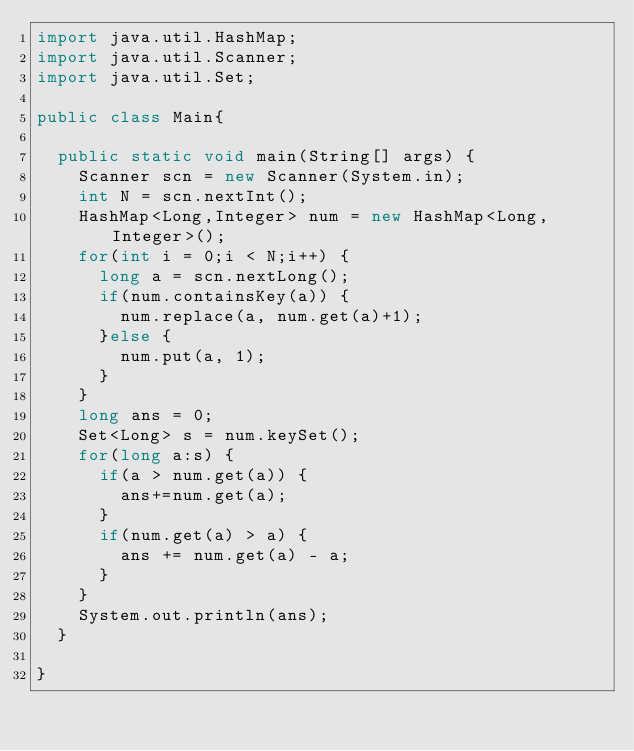Convert code to text. <code><loc_0><loc_0><loc_500><loc_500><_Java_>import java.util.HashMap;
import java.util.Scanner;
import java.util.Set;

public class Main{

	public static void main(String[] args) {
		Scanner scn = new Scanner(System.in);
		int N = scn.nextInt();
		HashMap<Long,Integer> num = new HashMap<Long,Integer>();
		for(int i = 0;i < N;i++) {
			long a = scn.nextLong();
			if(num.containsKey(a)) {
				num.replace(a, num.get(a)+1);
			}else {
				num.put(a, 1);
			}
		}
		long ans = 0;
		Set<Long> s = num.keySet();
		for(long a:s) {
			if(a > num.get(a)) {
				ans+=num.get(a);
			}
			if(num.get(a) > a) {
				ans += num.get(a) - a;
			}
		}
		System.out.println(ans);
	}

}
</code> 